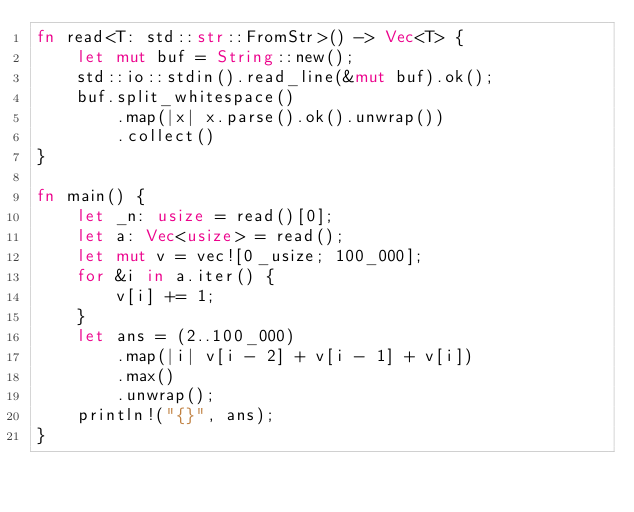<code> <loc_0><loc_0><loc_500><loc_500><_Rust_>fn read<T: std::str::FromStr>() -> Vec<T> {
    let mut buf = String::new();
    std::io::stdin().read_line(&mut buf).ok();
    buf.split_whitespace()
        .map(|x| x.parse().ok().unwrap())
        .collect()
}

fn main() {
    let _n: usize = read()[0];
    let a: Vec<usize> = read();
    let mut v = vec![0_usize; 100_000];
    for &i in a.iter() {
        v[i] += 1;
    }
    let ans = (2..100_000)
        .map(|i| v[i - 2] + v[i - 1] + v[i])
        .max()
        .unwrap();
    println!("{}", ans);
}
</code> 